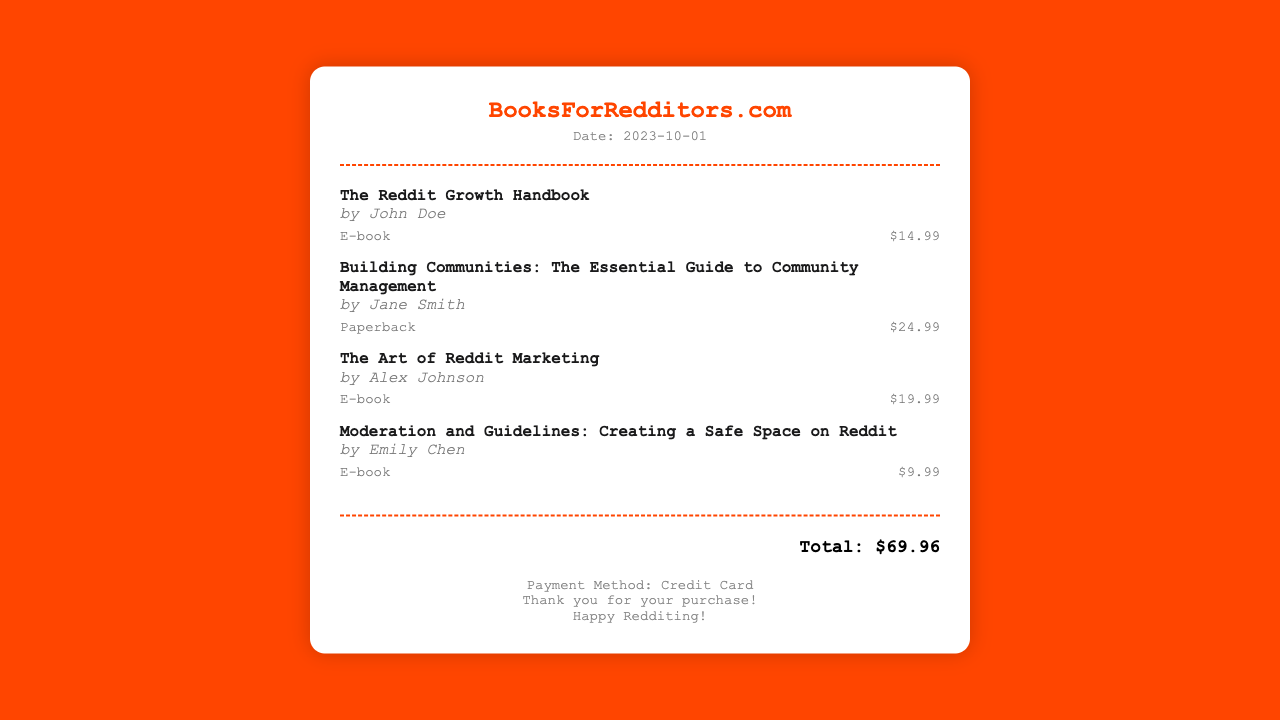What is the name of the first book listed? The first book listed in the document is "The Reddit Growth Handbook."
Answer: The Reddit Growth Handbook Who is the author of "Building Communities: The Essential Guide to Community Management"? The author of this book is Jane Smith.
Answer: Jane Smith What is the price of "The Art of Reddit Marketing"? The price of this book is stated in the document as $19.99.
Answer: $19.99 How many books are purchased according to the receipt? The receipt lists a total of four books.
Answer: 4 What type of payment method is mentioned in the receipt? The document specifies the payment method used for the purchase as credit card.
Answer: Credit Card What is the total amount spent on the books? The total amount for all the items purchased is mentioned at the end as $69.96.
Answer: $69.96 Who wrote "Moderation and Guidelines: Creating a Safe Space on Reddit"? The author for this book is Emily Chen.
Answer: Emily Chen What format is "The Reddit Growth Handbook" available in? The format of this book is specified as an e-book.
Answer: E-book 